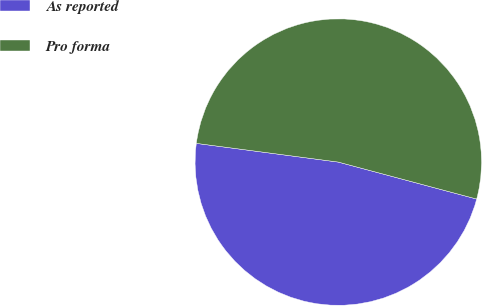Convert chart to OTSL. <chart><loc_0><loc_0><loc_500><loc_500><pie_chart><fcel>As reported<fcel>Pro forma<nl><fcel>47.93%<fcel>52.07%<nl></chart> 